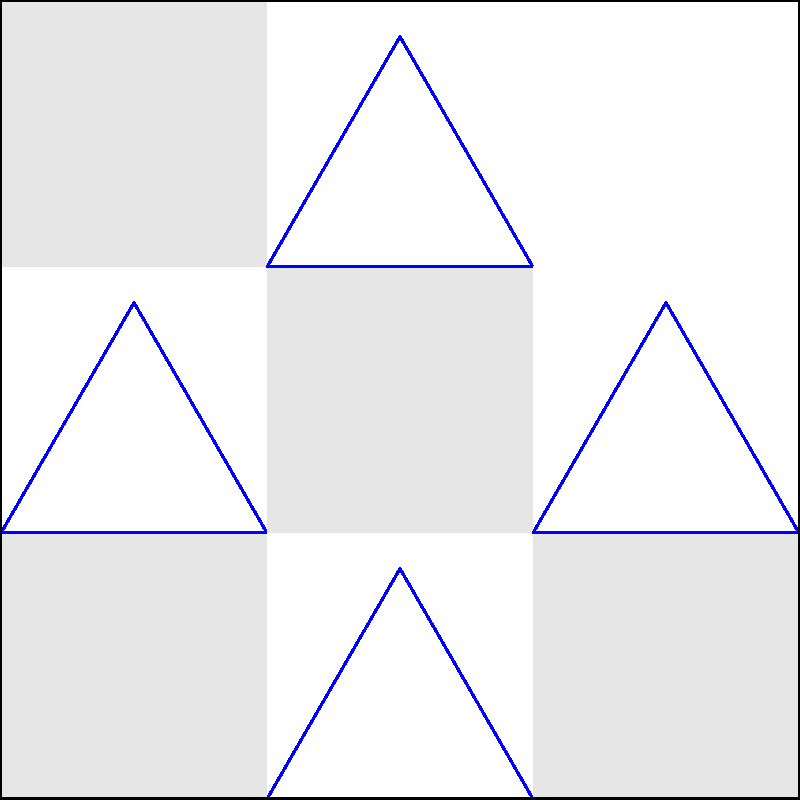In this 3x3 grid pattern, each square alternates between light gray and white. The white squares contain a blue triangle. Which shape should fill the missing bottom-right square to complete the pattern? To determine the missing piece, let's analyze the pattern step-by-step:

1. The grid follows an alternating color pattern:
   - Light gray squares are in positions (1,1), (1,3), (2,2), (3,1), (3,3)
   - White squares are in positions (1,2), (2,1), (2,3), (3,2)

2. The blue triangles appear only in the white squares.

3. The missing square is in position (3,3), which should be light gray based on the alternating pattern.

4. Light gray squares do not contain blue triangles.

Therefore, the missing piece should be a light gray square without a blue triangle to maintain the established pattern.
Answer: Light gray square 